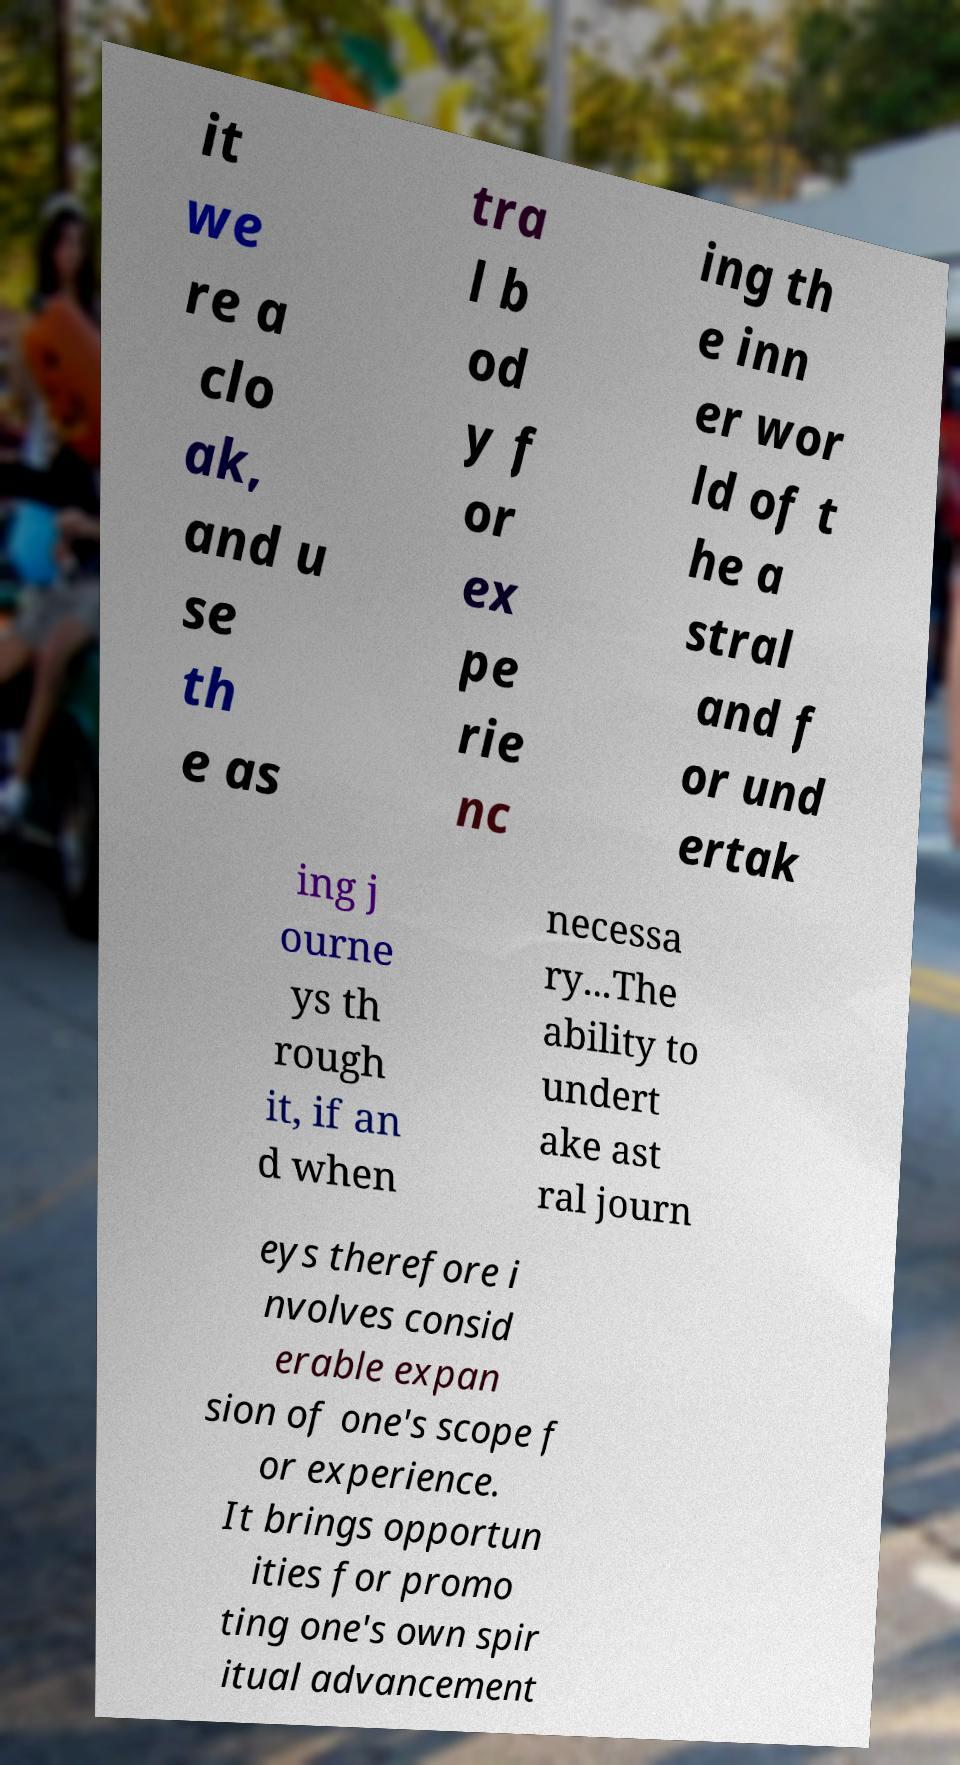Please identify and transcribe the text found in this image. it we re a clo ak, and u se th e as tra l b od y f or ex pe rie nc ing th e inn er wor ld of t he a stral and f or und ertak ing j ourne ys th rough it, if an d when necessa ry...The ability to undert ake ast ral journ eys therefore i nvolves consid erable expan sion of one's scope f or experience. It brings opportun ities for promo ting one's own spir itual advancement 